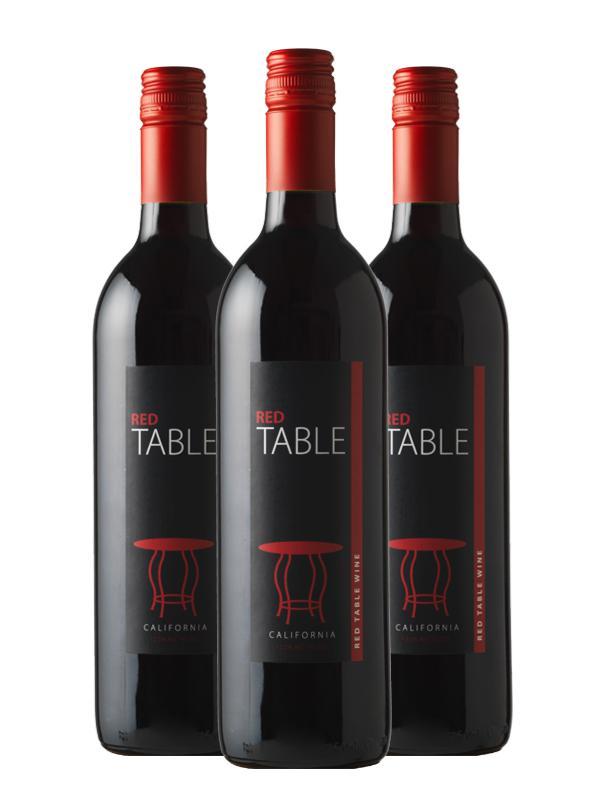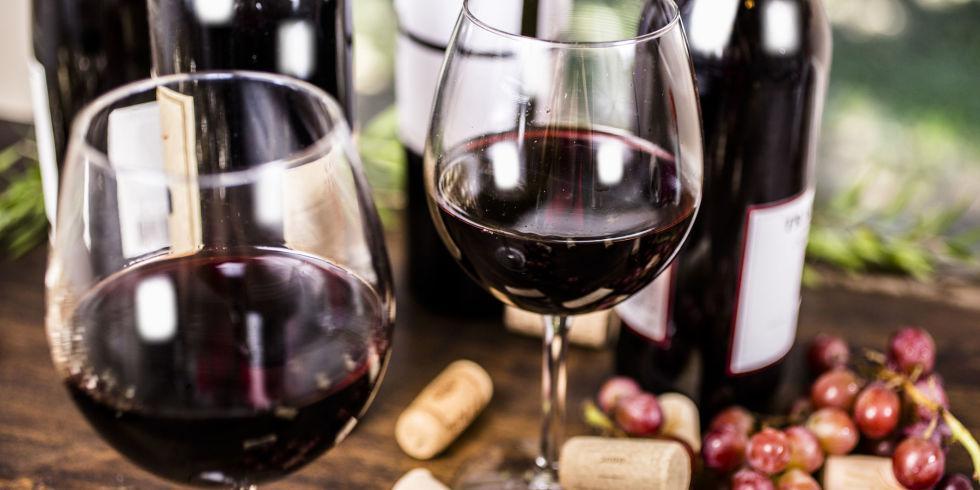The first image is the image on the left, the second image is the image on the right. Evaluate the accuracy of this statement regarding the images: "there is exactly one bottle in the image on the right". Is it true? Answer yes or no. No. The first image is the image on the left, the second image is the image on the right. For the images shown, is this caption "An image shows wine bottle, glass, grapes and green leaves." true? Answer yes or no. No. 